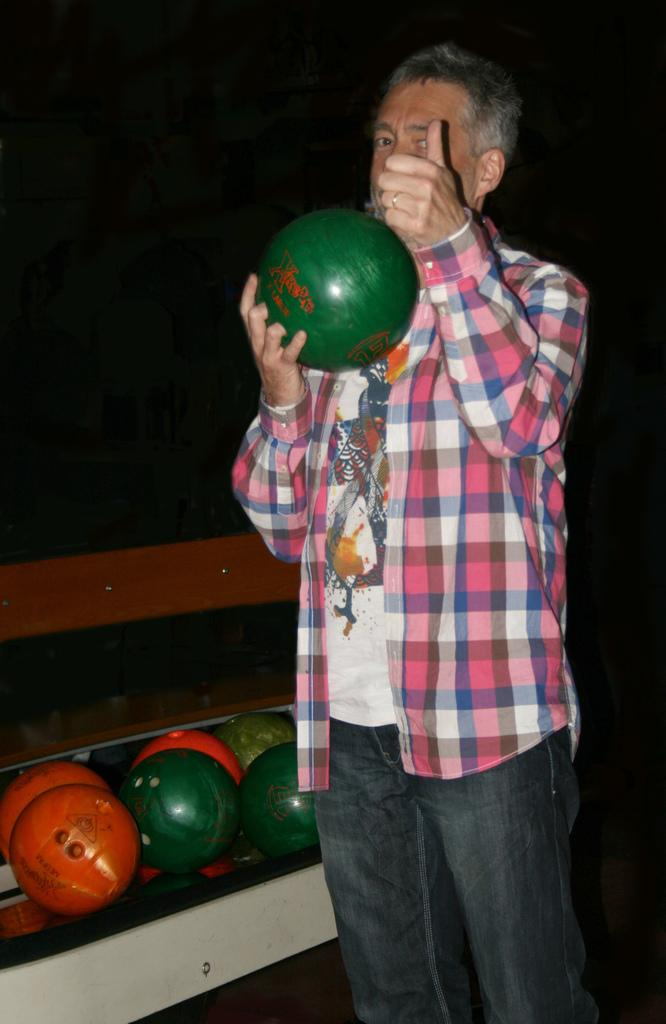Who is present in the image? There is a man in the image. What is the man holding in the image? The man is holding a ball. What else can be seen related to balls in the image? There is a group of balls placed on a surface in the image. What type of insurance policy is the man discussing with the plants in the image? There are no plants present in the image, and the man is not discussing any insurance policies. 